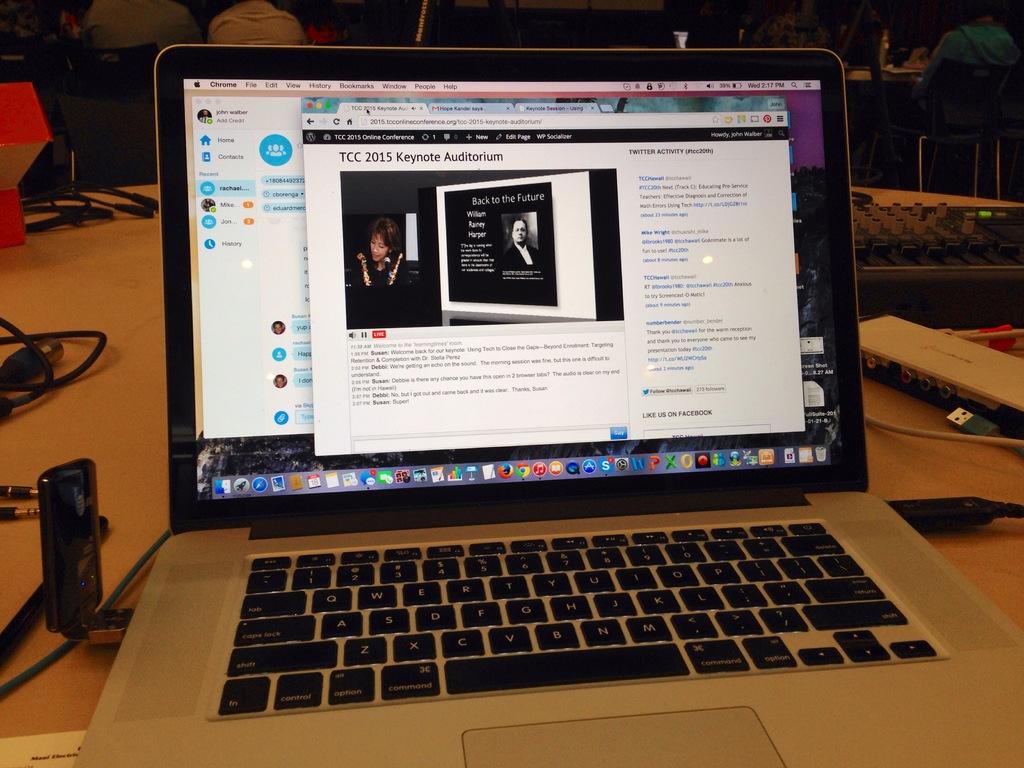What year is in the electronic article title?
Ensure brevity in your answer.  2015. Is there a "chrome" tab on this screen?
Ensure brevity in your answer.  Yes. 